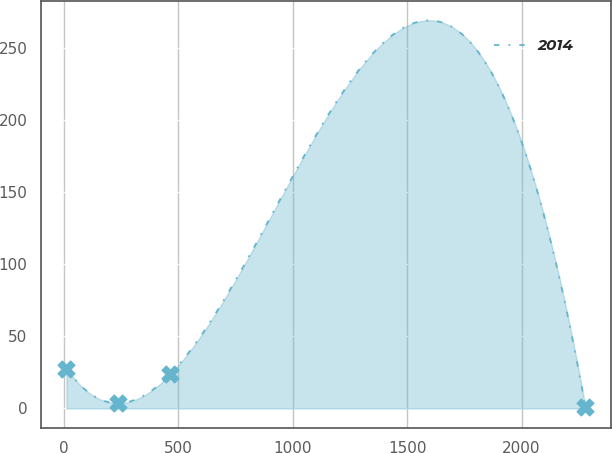<chart> <loc_0><loc_0><loc_500><loc_500><line_chart><ecel><fcel>2014<nl><fcel>10.54<fcel>27.69<nl><fcel>237.39<fcel>3.68<nl><fcel>464.24<fcel>23.77<nl><fcel>2279.03<fcel>1.01<nl></chart> 